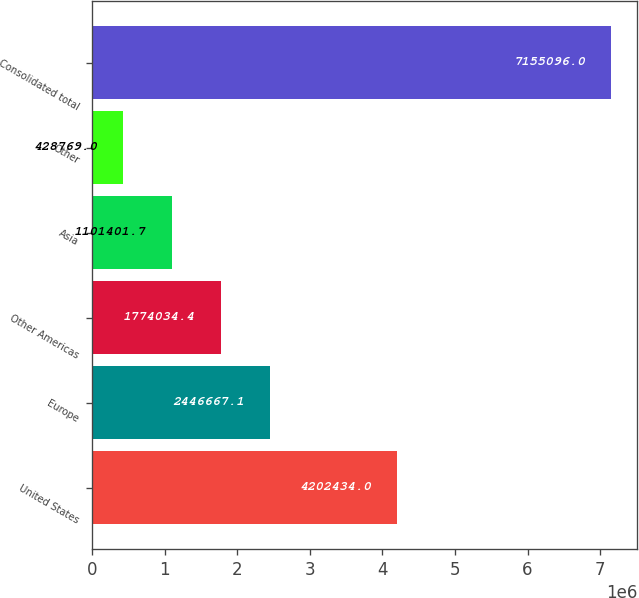Convert chart to OTSL. <chart><loc_0><loc_0><loc_500><loc_500><bar_chart><fcel>United States<fcel>Europe<fcel>Other Americas<fcel>Asia<fcel>Other<fcel>Consolidated total<nl><fcel>4.20243e+06<fcel>2.44667e+06<fcel>1.77403e+06<fcel>1.1014e+06<fcel>428769<fcel>7.1551e+06<nl></chart> 